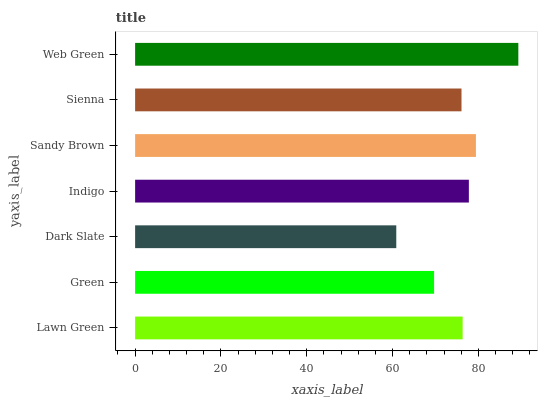Is Dark Slate the minimum?
Answer yes or no. Yes. Is Web Green the maximum?
Answer yes or no. Yes. Is Green the minimum?
Answer yes or no. No. Is Green the maximum?
Answer yes or no. No. Is Lawn Green greater than Green?
Answer yes or no. Yes. Is Green less than Lawn Green?
Answer yes or no. Yes. Is Green greater than Lawn Green?
Answer yes or no. No. Is Lawn Green less than Green?
Answer yes or no. No. Is Lawn Green the high median?
Answer yes or no. Yes. Is Lawn Green the low median?
Answer yes or no. Yes. Is Green the high median?
Answer yes or no. No. Is Sienna the low median?
Answer yes or no. No. 